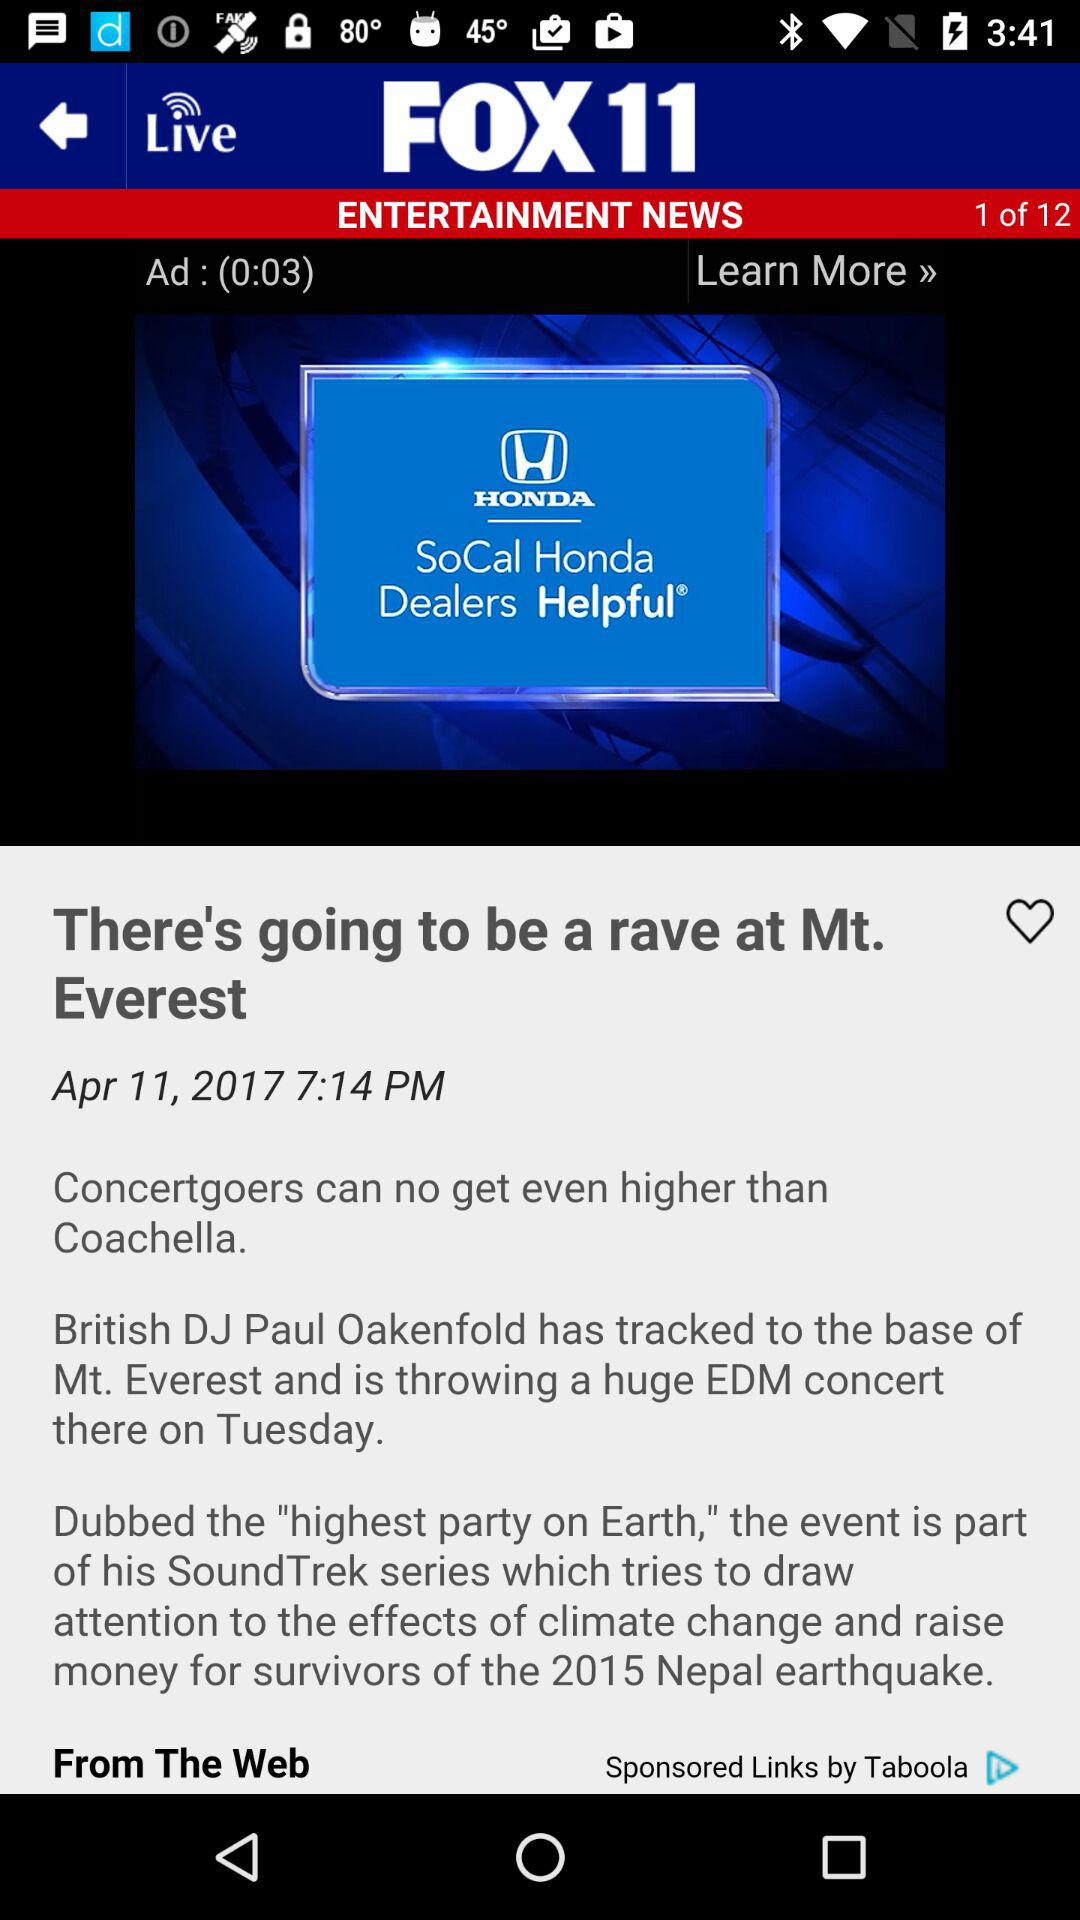What is the date and time? The date and time is April 11, 2017, at 7:14 PM. 